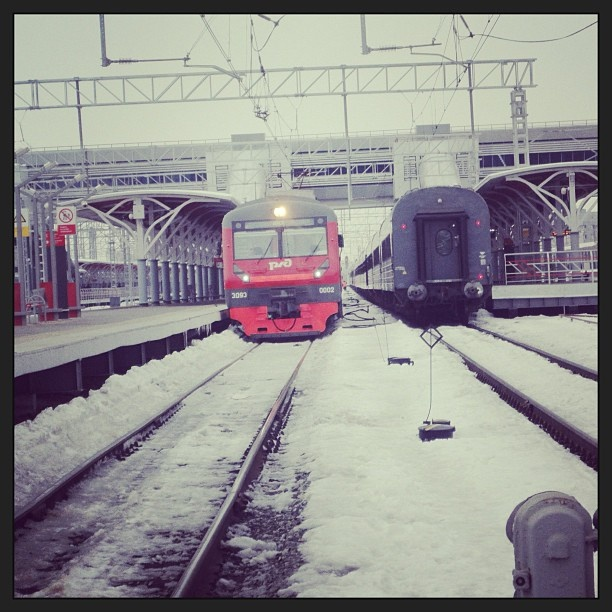Describe the objects in this image and their specific colors. I can see train in black, darkgray, purple, and salmon tones and train in black, purple, navy, and gray tones in this image. 